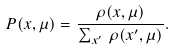Convert formula to latex. <formula><loc_0><loc_0><loc_500><loc_500>P ( x , \mu ) = \frac { \rho ( x , \mu ) } { \sum _ { x ^ { \prime } } \, \rho ( x ^ { \prime } , \mu ) } .</formula> 